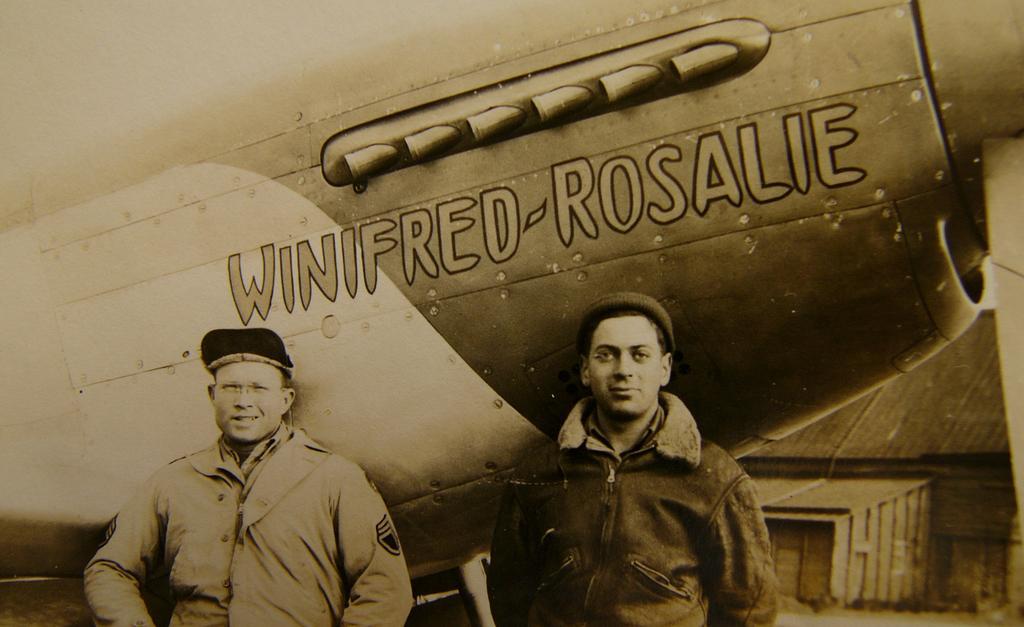Describe this image in one or two sentences. This is the picture of a black and white image and we can see two people standing and posing for a photo and in the background, we can see an object which looks like an aircraft. 